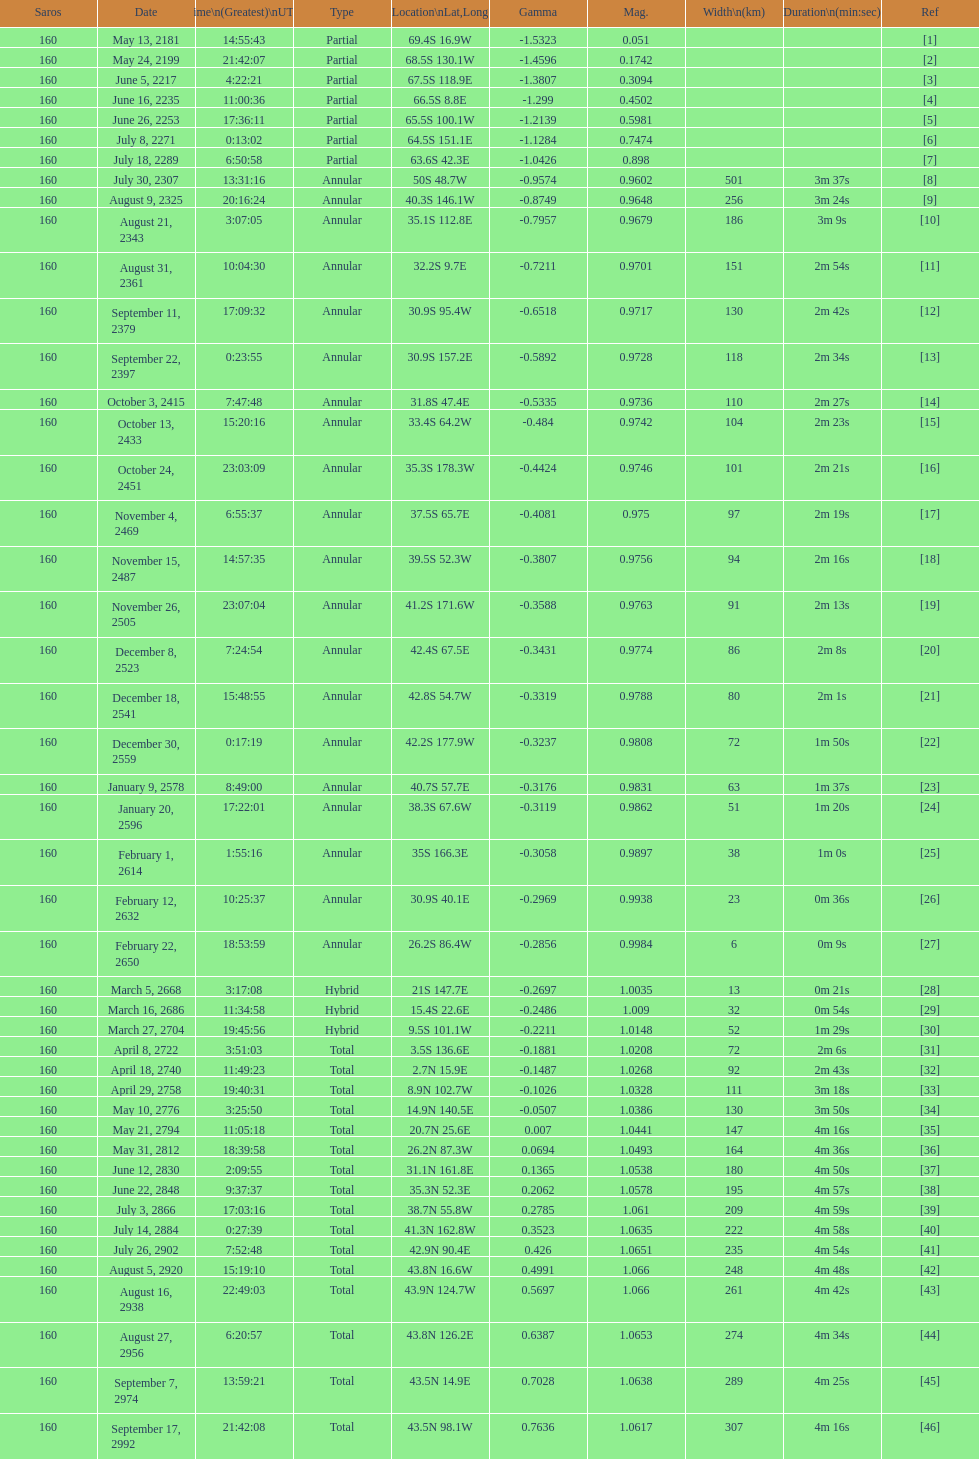When did the first solar saros with a magnitude of greater than 1.00 occur? March 5, 2668. 